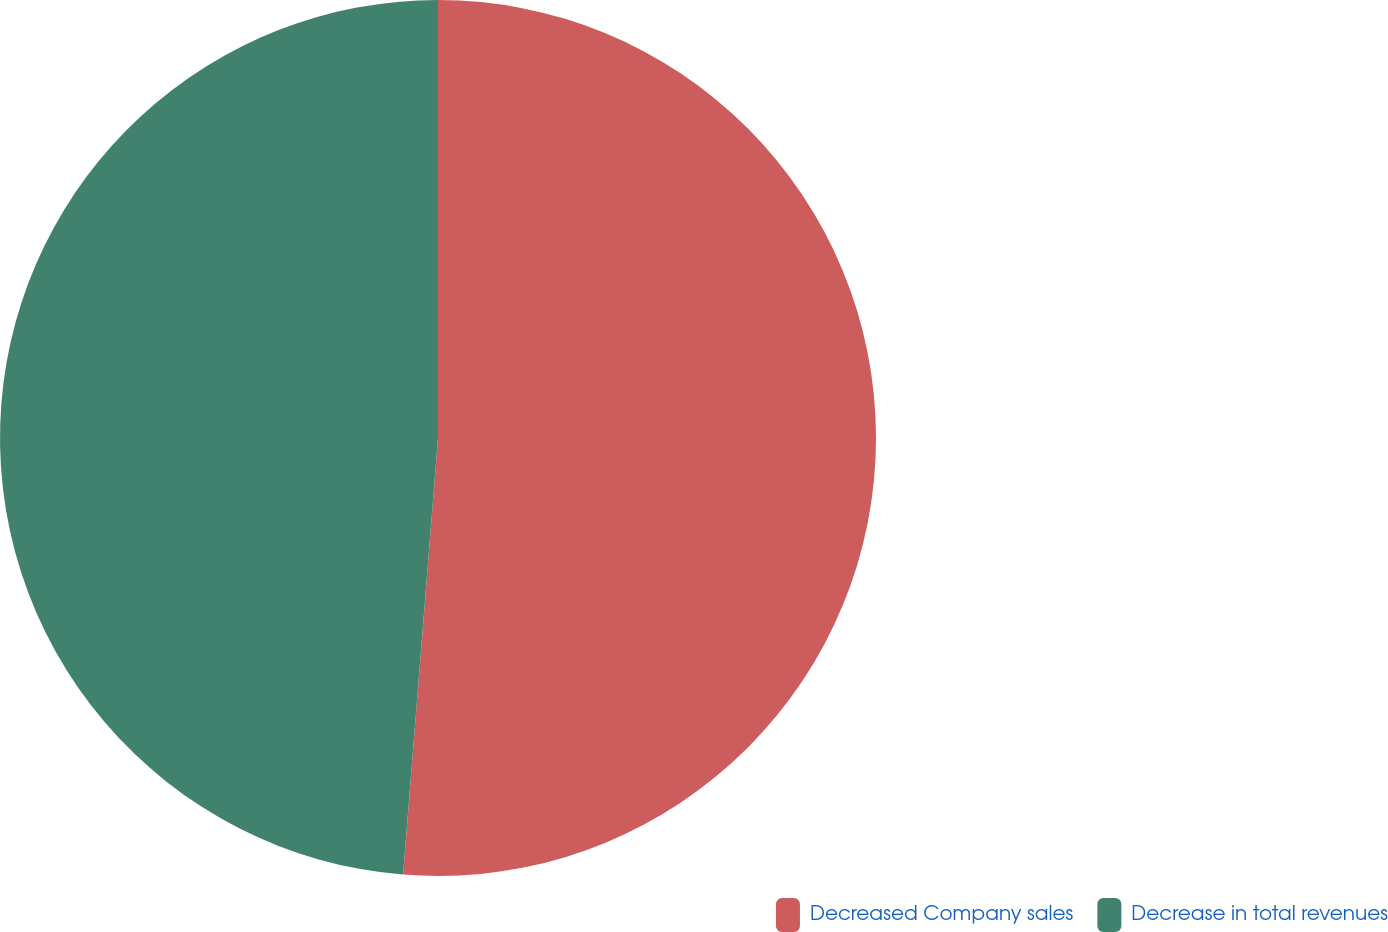Convert chart. <chart><loc_0><loc_0><loc_500><loc_500><pie_chart><fcel>Decreased Company sales<fcel>Decrease in total revenues<nl><fcel>51.27%<fcel>48.73%<nl></chart> 